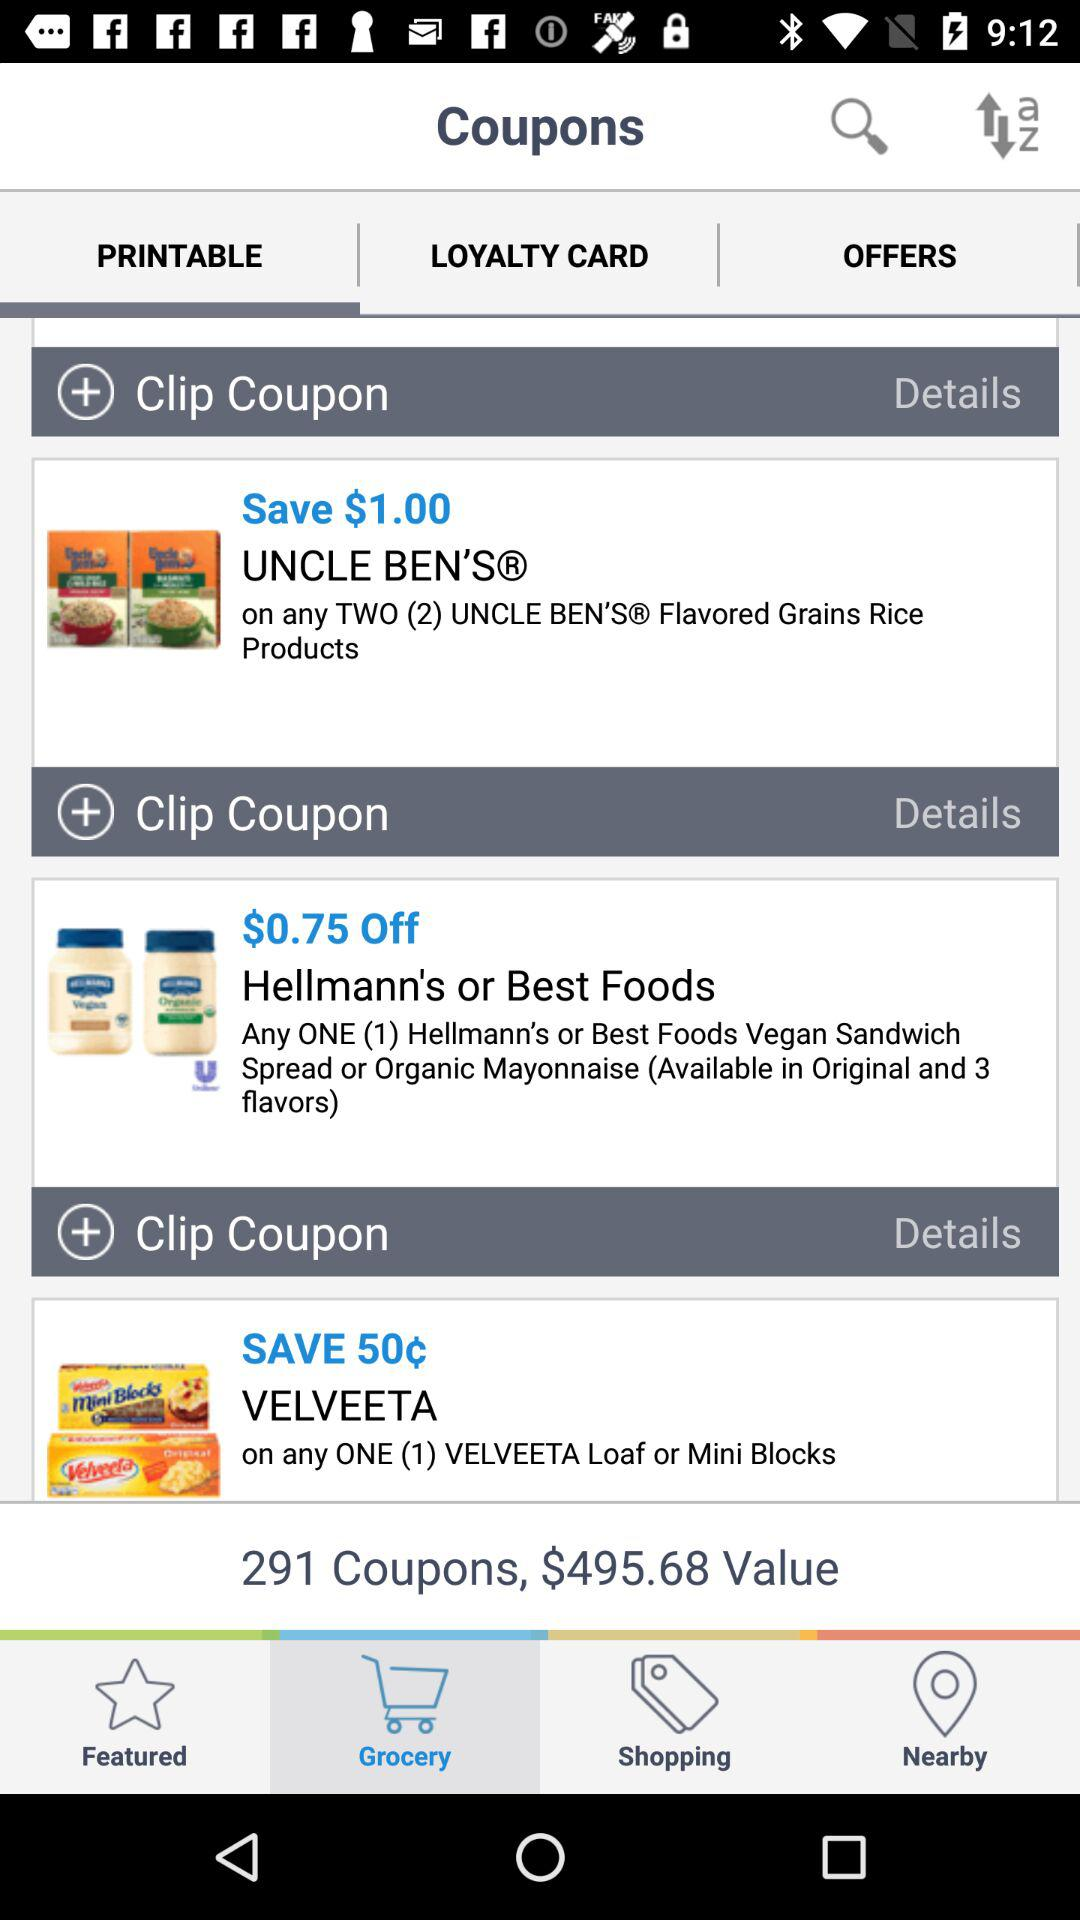What is the currency for the value of coupons? The currency for the value of coupons is dollars. 